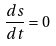<formula> <loc_0><loc_0><loc_500><loc_500>\frac { d s } { d t } = 0</formula> 